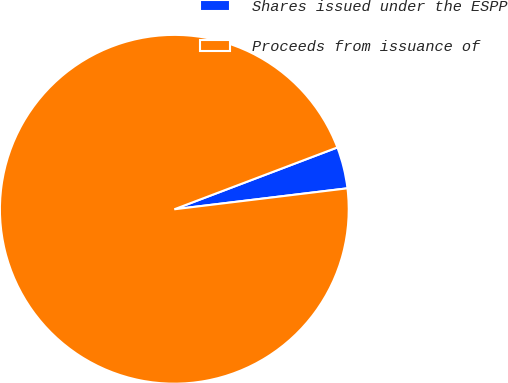Convert chart to OTSL. <chart><loc_0><loc_0><loc_500><loc_500><pie_chart><fcel>Shares issued under the ESPP<fcel>Proceeds from issuance of<nl><fcel>3.85%<fcel>96.15%<nl></chart> 